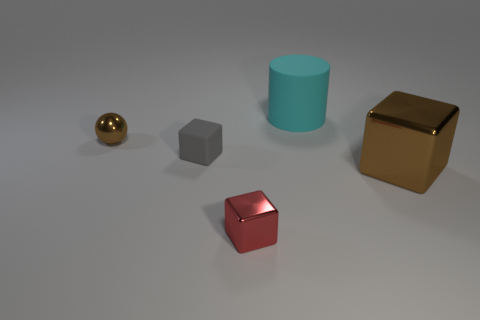Could you tell me the purpose of these objects presented here? Based on the image, these objects do not appear to have a specific functional purpose. They seem to be artistic 3D renderings used to illustrate different geometric shapes and shadows. The spheres, cylinder, and cubes might be part of a visualization in computer graphics work, possibly related to an exercise in shading, lighting, or texturing. 